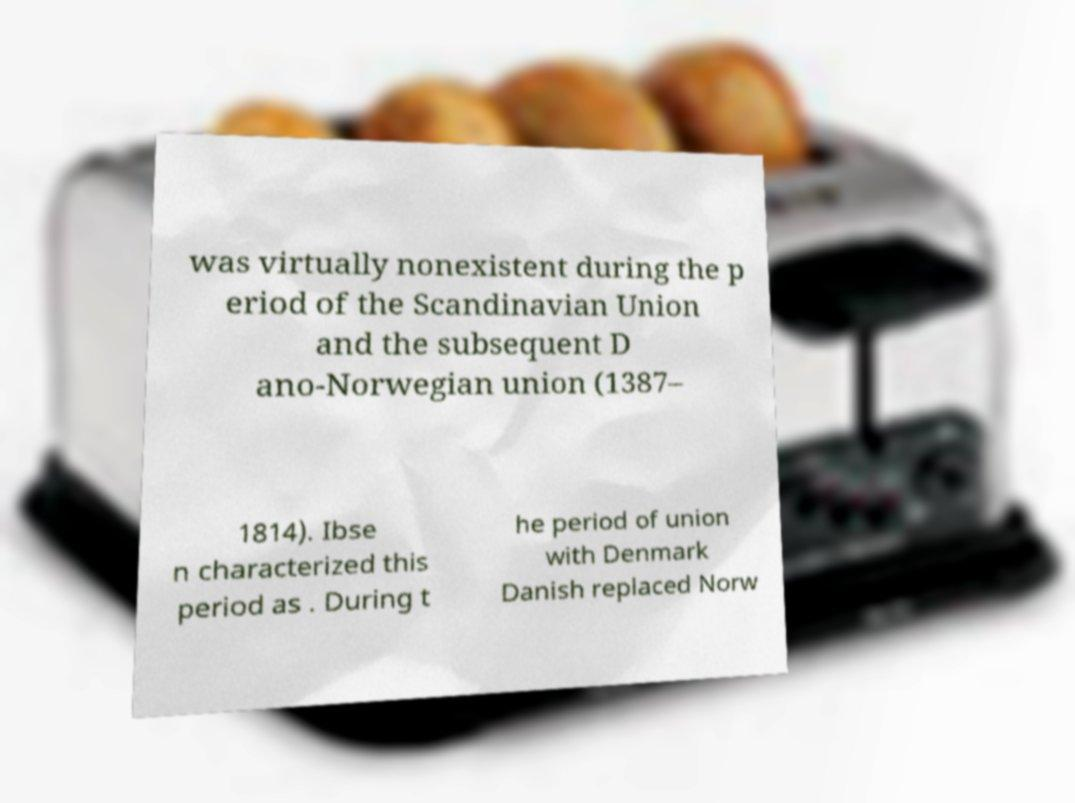Could you extract and type out the text from this image? was virtually nonexistent during the p eriod of the Scandinavian Union and the subsequent D ano-Norwegian union (1387– 1814). Ibse n characterized this period as . During t he period of union with Denmark Danish replaced Norw 